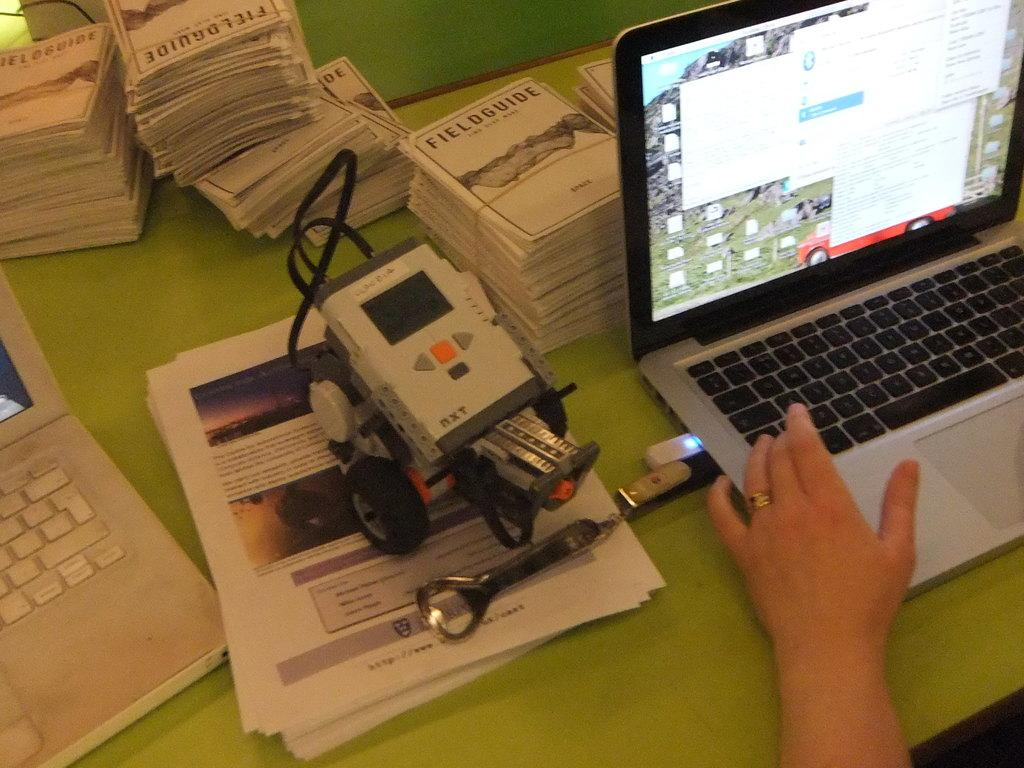<image>
Summarize the visual content of the image. A view of a green desk with a person on a computer and a stack of Fieldguides. 